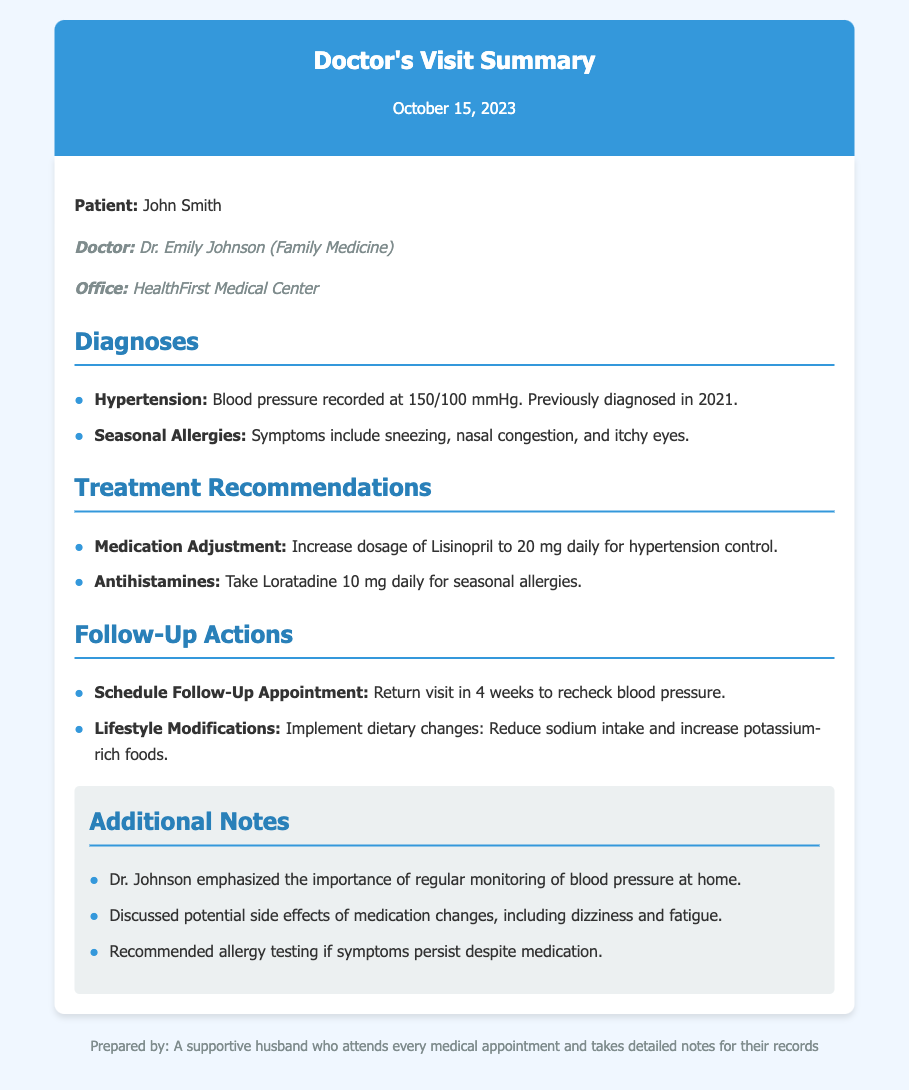What is the date of the doctor’s visit? The date is mentioned prominently at the top of the document under the title.
Answer: October 15, 2023 Who is the patient? The patient's name is provided as a part of the introductory information.
Answer: John Smith What is the blood pressure recorded during the visit? The blood pressure is specified under the diagnosis section for hypertension.
Answer: 150/100 mmHg What medication was increased for hypertension? The medication adjustment is detailed in the treatment recommendations section.
Answer: Lisinopril When is the follow-up appointment scheduled? The time frame for the follow-up appointment is provided in the follow-up actions section.
Answer: In 4 weeks What symptoms are associated with seasonal allergies? The symptoms are listed in the diagnosis section related to seasonal allergies.
Answer: Sneezing, nasal congestion, and itchy eyes What lifestyle modification was recommended? The document suggests specific dietary changes under follow-up actions.
Answer: Reduce sodium intake What is the doctor’s name? The doctor’s name is stated in the introductory information.
Answer: Dr. Emily Johnson What additional action was discussed if allergy symptoms persist? This action is mentioned as part of the additional notes section.
Answer: Allergy testing 